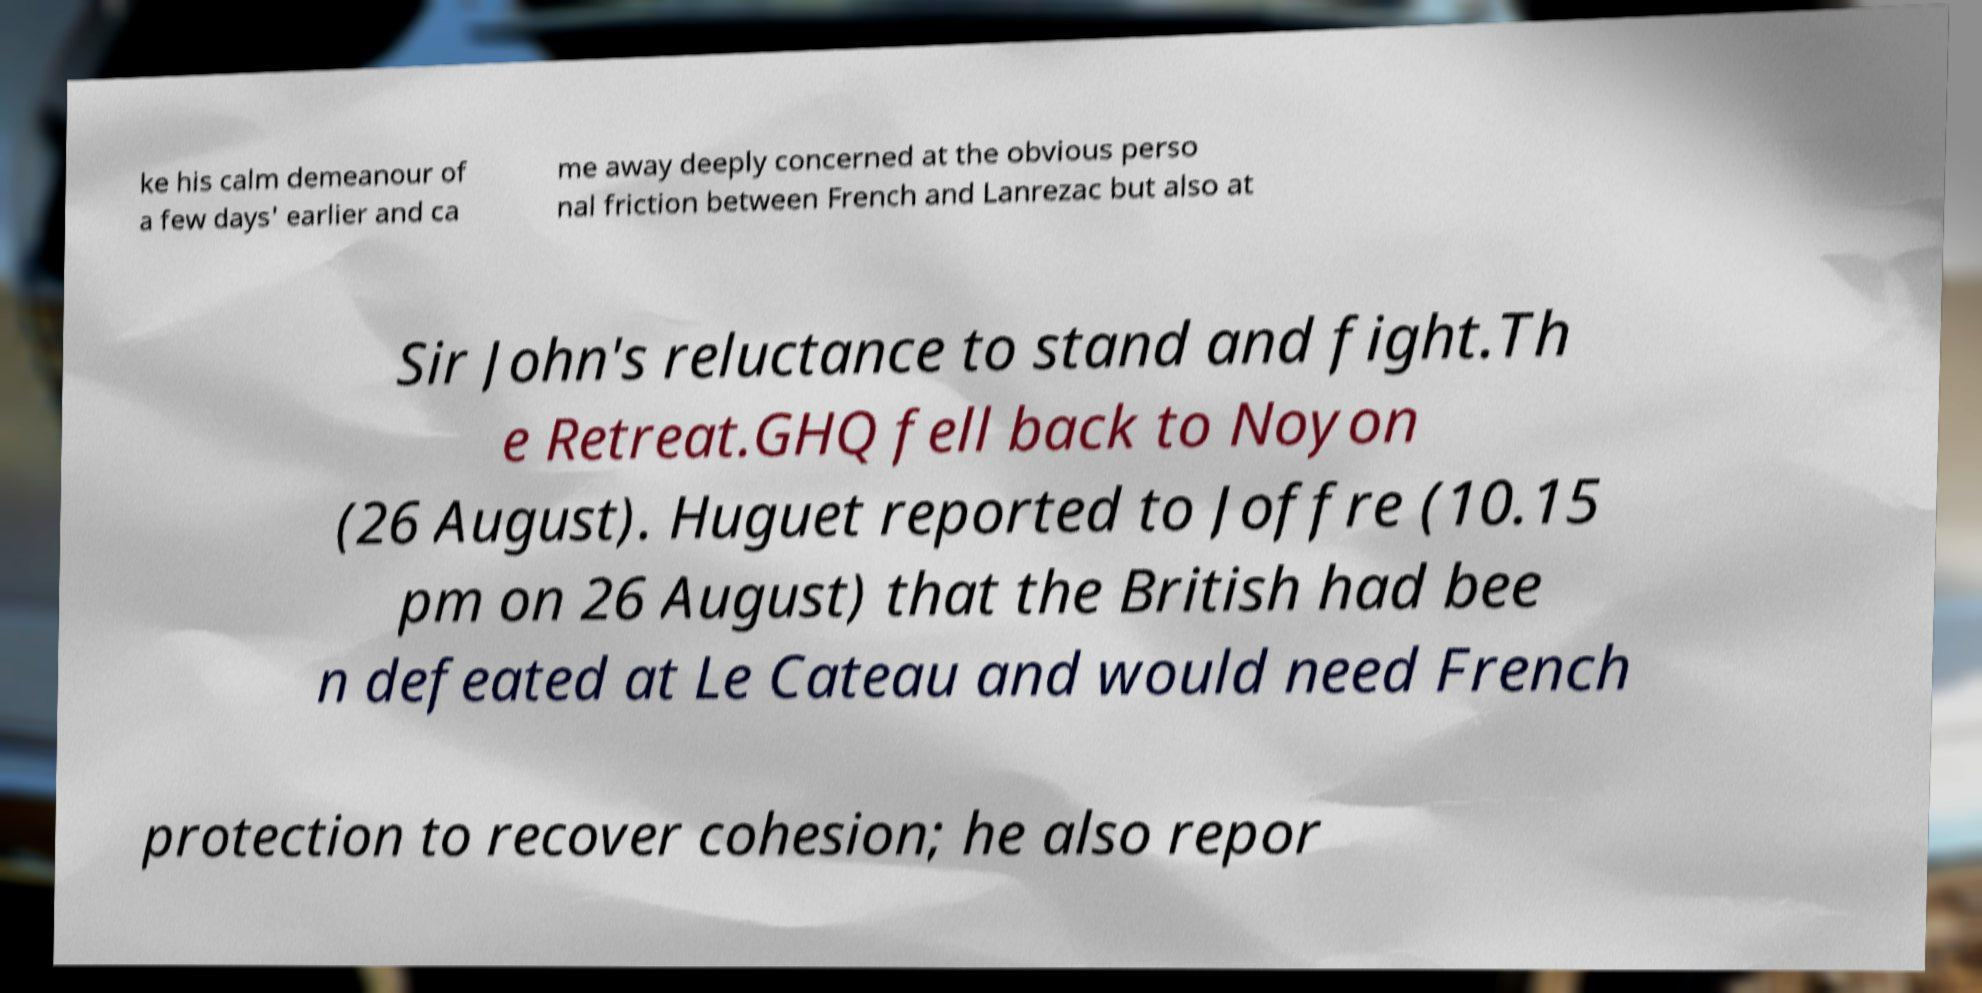There's text embedded in this image that I need extracted. Can you transcribe it verbatim? ke his calm demeanour of a few days' earlier and ca me away deeply concerned at the obvious perso nal friction between French and Lanrezac but also at Sir John's reluctance to stand and fight.Th e Retreat.GHQ fell back to Noyon (26 August). Huguet reported to Joffre (10.15 pm on 26 August) that the British had bee n defeated at Le Cateau and would need French protection to recover cohesion; he also repor 